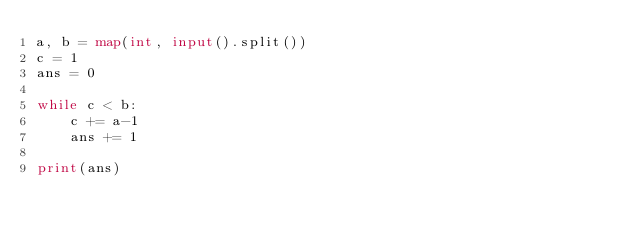Convert code to text. <code><loc_0><loc_0><loc_500><loc_500><_Python_>a, b = map(int, input().split())
c = 1
ans = 0

while c < b:
    c += a-1
    ans += 1

print(ans)</code> 